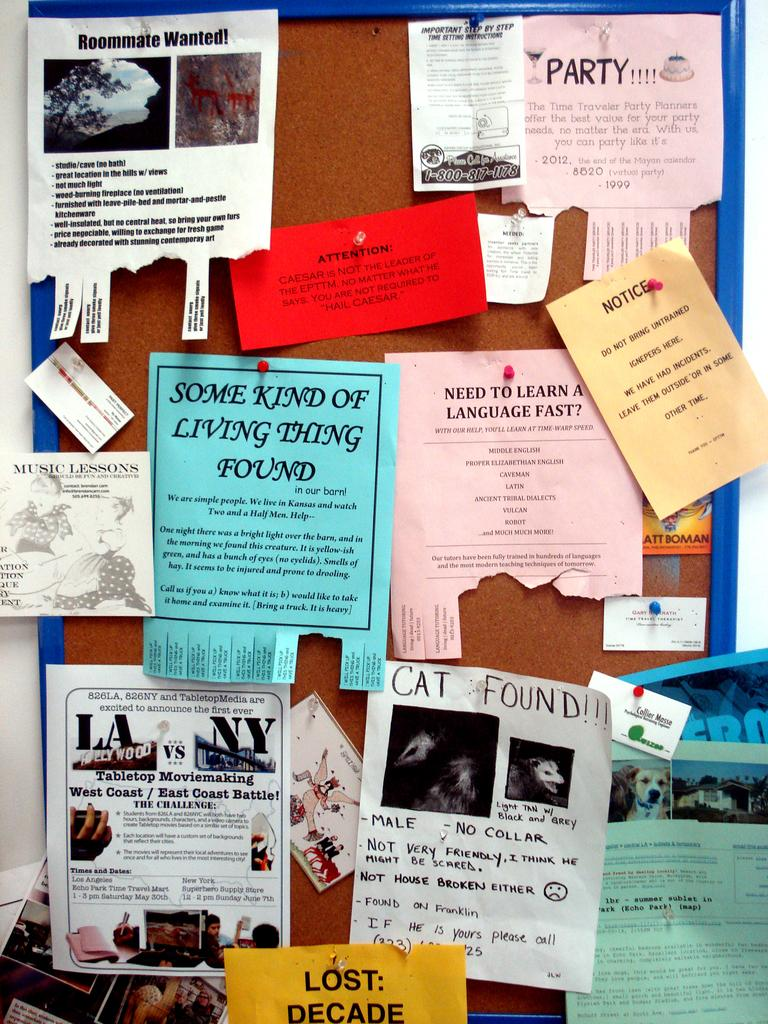<image>
Write a terse but informative summary of the picture. a paper that says a cat was found 